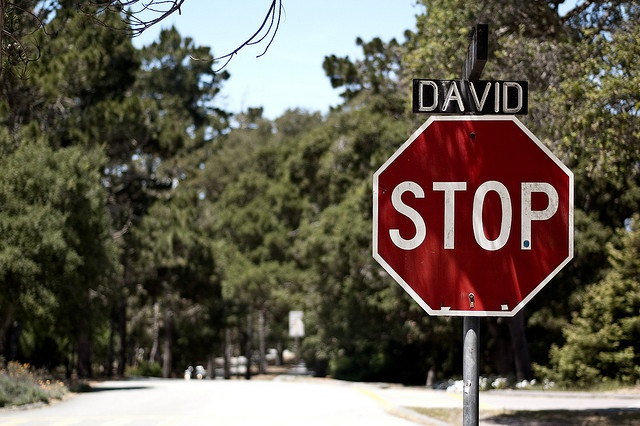Describe the objects in this image and their specific colors. I can see stop sign in black, maroon, lightgray, and brown tones, car in black, gray, darkgray, and lightgray tones, and car in black, lightgray, gray, and darkgray tones in this image. 